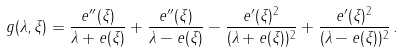Convert formula to latex. <formula><loc_0><loc_0><loc_500><loc_500>g ( \lambda , \xi ) = \frac { e ^ { \prime \prime } ( \xi ) } { \lambda + e ( \xi ) } + \frac { e ^ { \prime \prime } ( \xi ) } { \lambda - e ( \xi ) } - \frac { e ^ { \prime } ( \xi ) ^ { 2 } } { ( \lambda + e ( \xi ) ) ^ { 2 } } + \frac { e ^ { \prime } ( \xi ) ^ { 2 } } { ( \lambda - e ( \xi ) ) ^ { 2 } } \, .</formula> 